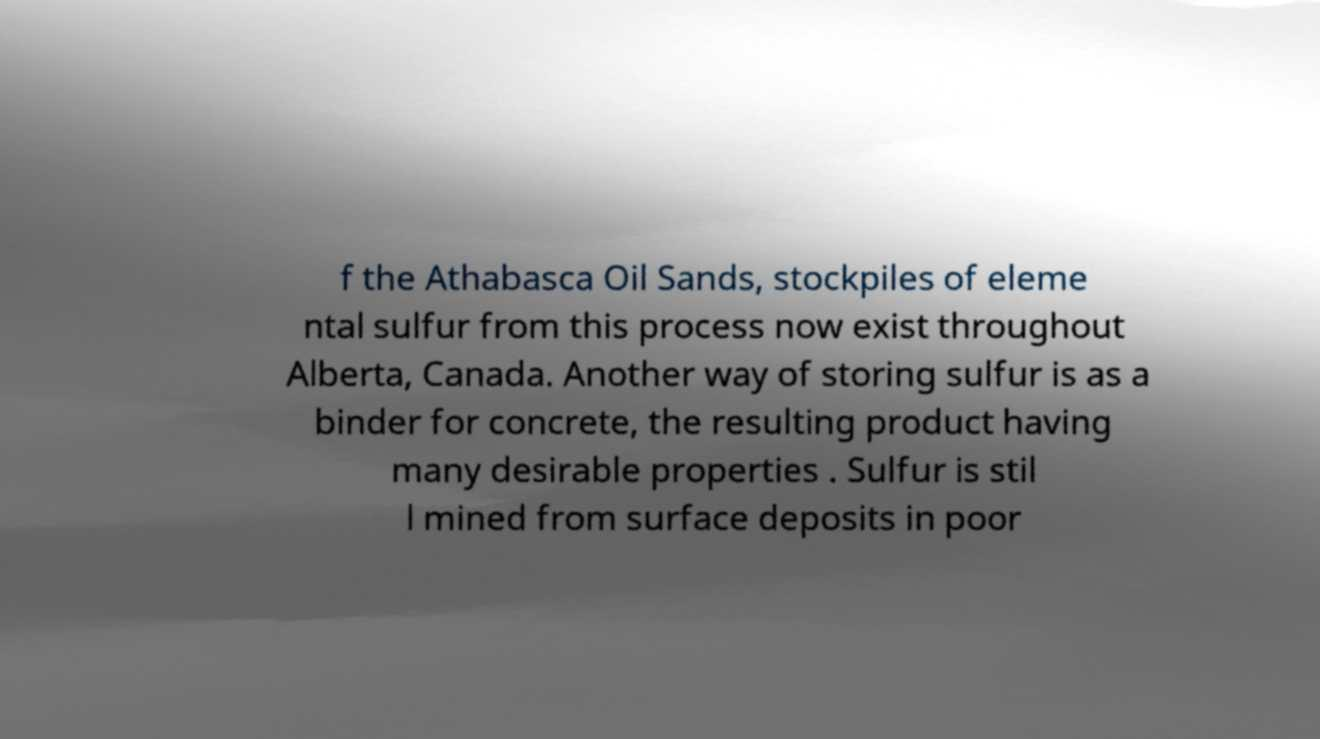Please identify and transcribe the text found in this image. f the Athabasca Oil Sands, stockpiles of eleme ntal sulfur from this process now exist throughout Alberta, Canada. Another way of storing sulfur is as a binder for concrete, the resulting product having many desirable properties . Sulfur is stil l mined from surface deposits in poor 